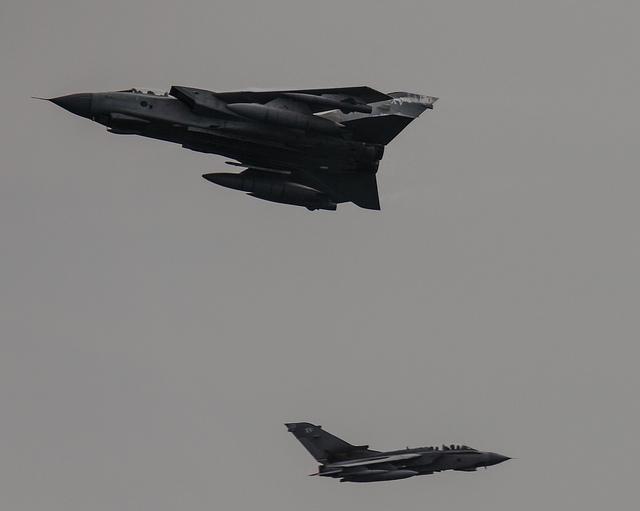What color are the planes?
Keep it brief. Gray. How many planes are there?
Short answer required. 2. Are they both facing the same direction?
Keep it brief. No. 